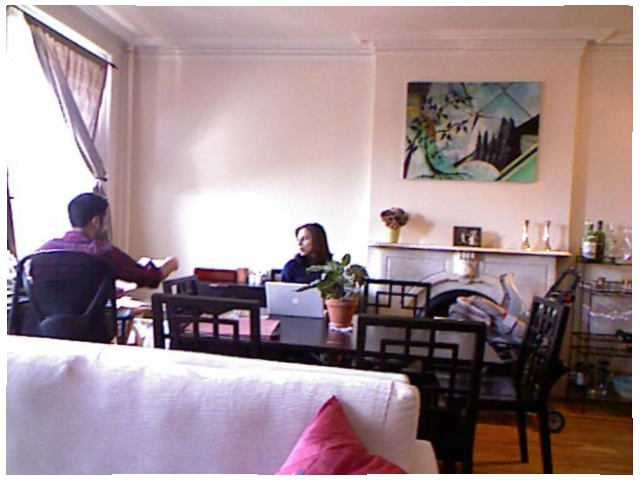<image>
Is the woman on the chair? No. The woman is not positioned on the chair. They may be near each other, but the woman is not supported by or resting on top of the chair. Is there a wall behind the painting? Yes. From this viewpoint, the wall is positioned behind the painting, with the painting partially or fully occluding the wall. Is there a wall behind the women? Yes. From this viewpoint, the wall is positioned behind the women, with the women partially or fully occluding the wall. Is the baby behind the chair? No. The baby is not behind the chair. From this viewpoint, the baby appears to be positioned elsewhere in the scene. Where is the chair in relation to the chair? Is it to the left of the chair? No. The chair is not to the left of the chair. From this viewpoint, they have a different horizontal relationship. 